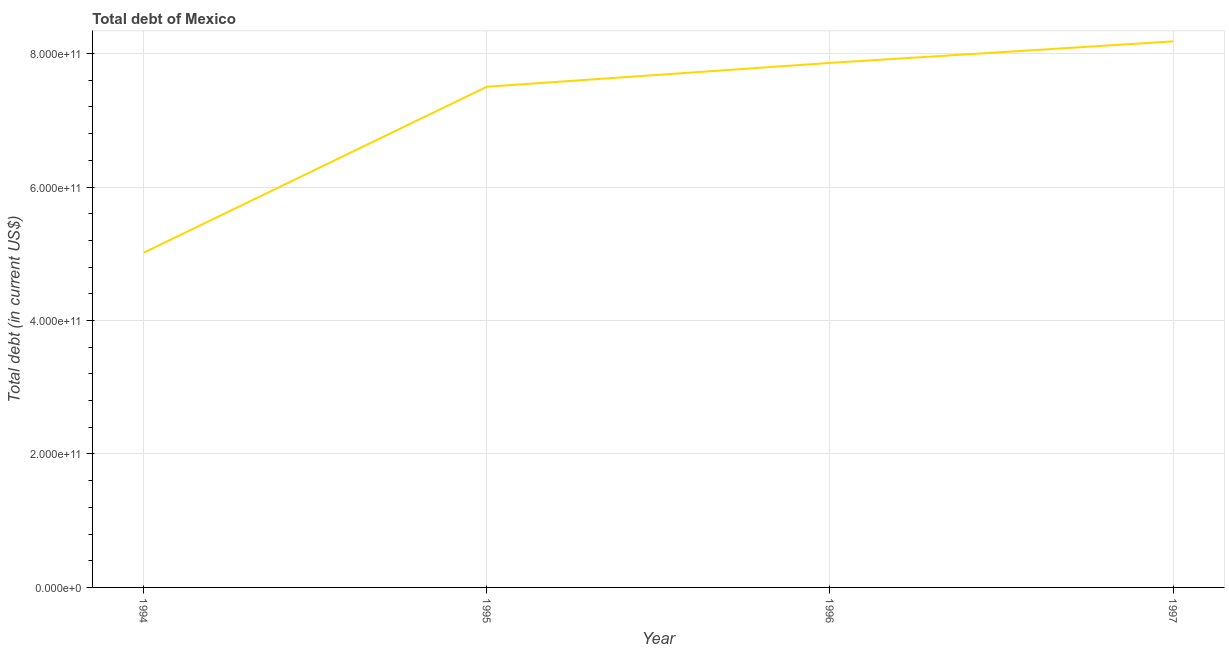What is the total debt in 1994?
Your answer should be very brief. 5.02e+11. Across all years, what is the maximum total debt?
Give a very brief answer. 8.18e+11. Across all years, what is the minimum total debt?
Make the answer very short. 5.02e+11. In which year was the total debt maximum?
Your response must be concise. 1997. In which year was the total debt minimum?
Ensure brevity in your answer.  1994. What is the sum of the total debt?
Your answer should be very brief. 2.86e+12. What is the difference between the total debt in 1994 and 1997?
Offer a very short reply. -3.17e+11. What is the average total debt per year?
Keep it short and to the point. 7.14e+11. What is the median total debt?
Your answer should be very brief. 7.68e+11. Do a majority of the years between 1995 and 1996 (inclusive) have total debt greater than 560000000000 US$?
Give a very brief answer. Yes. What is the ratio of the total debt in 1994 to that in 1997?
Your response must be concise. 0.61. What is the difference between the highest and the second highest total debt?
Provide a succinct answer. 3.22e+1. What is the difference between the highest and the lowest total debt?
Keep it short and to the point. 3.17e+11. What is the difference between two consecutive major ticks on the Y-axis?
Offer a terse response. 2.00e+11. Are the values on the major ticks of Y-axis written in scientific E-notation?
Your response must be concise. Yes. What is the title of the graph?
Make the answer very short. Total debt of Mexico. What is the label or title of the X-axis?
Your answer should be compact. Year. What is the label or title of the Y-axis?
Ensure brevity in your answer.  Total debt (in current US$). What is the Total debt (in current US$) in 1994?
Provide a succinct answer. 5.02e+11. What is the Total debt (in current US$) in 1995?
Ensure brevity in your answer.  7.50e+11. What is the Total debt (in current US$) in 1996?
Your answer should be compact. 7.86e+11. What is the Total debt (in current US$) of 1997?
Provide a succinct answer. 8.18e+11. What is the difference between the Total debt (in current US$) in 1994 and 1995?
Your answer should be compact. -2.49e+11. What is the difference between the Total debt (in current US$) in 1994 and 1996?
Ensure brevity in your answer.  -2.84e+11. What is the difference between the Total debt (in current US$) in 1994 and 1997?
Offer a terse response. -3.17e+11. What is the difference between the Total debt (in current US$) in 1995 and 1996?
Offer a terse response. -3.57e+1. What is the difference between the Total debt (in current US$) in 1995 and 1997?
Your answer should be very brief. -6.80e+1. What is the difference between the Total debt (in current US$) in 1996 and 1997?
Offer a terse response. -3.22e+1. What is the ratio of the Total debt (in current US$) in 1994 to that in 1995?
Offer a terse response. 0.67. What is the ratio of the Total debt (in current US$) in 1994 to that in 1996?
Make the answer very short. 0.64. What is the ratio of the Total debt (in current US$) in 1994 to that in 1997?
Your response must be concise. 0.61. What is the ratio of the Total debt (in current US$) in 1995 to that in 1996?
Your response must be concise. 0.95. What is the ratio of the Total debt (in current US$) in 1995 to that in 1997?
Keep it short and to the point. 0.92. What is the ratio of the Total debt (in current US$) in 1996 to that in 1997?
Your answer should be compact. 0.96. 